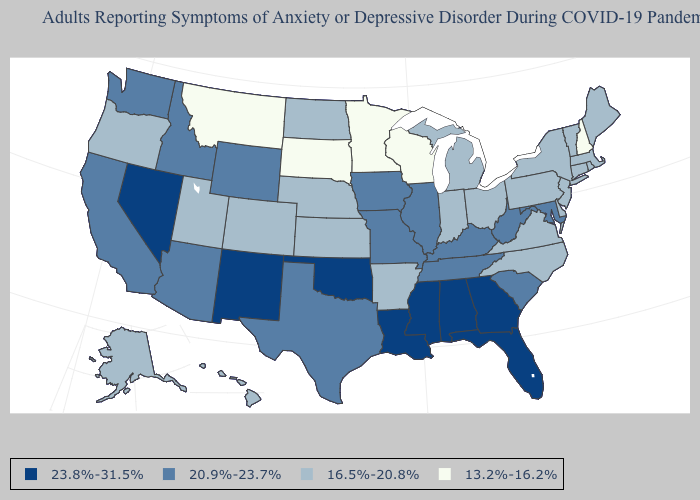Among the states that border Arizona , which have the lowest value?
Short answer required. Colorado, Utah. Does the map have missing data?
Write a very short answer. No. What is the value of Michigan?
Answer briefly. 16.5%-20.8%. What is the value of Ohio?
Quick response, please. 16.5%-20.8%. Does Hawaii have the highest value in the USA?
Write a very short answer. No. What is the value of Illinois?
Concise answer only. 20.9%-23.7%. Is the legend a continuous bar?
Short answer required. No. Does New Mexico have a higher value than Alaska?
Write a very short answer. Yes. What is the highest value in the MidWest ?
Be succinct. 20.9%-23.7%. Among the states that border South Dakota , does Montana have the highest value?
Be succinct. No. Which states have the lowest value in the MidWest?
Quick response, please. Minnesota, South Dakota, Wisconsin. Does the map have missing data?
Give a very brief answer. No. What is the value of Texas?
Quick response, please. 20.9%-23.7%. Does Michigan have the lowest value in the MidWest?
Keep it brief. No. 